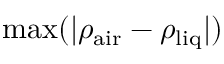Convert formula to latex. <formula><loc_0><loc_0><loc_500><loc_500>\max ( | \rho _ { a i r } - \rho _ { l i q } | )</formula> 